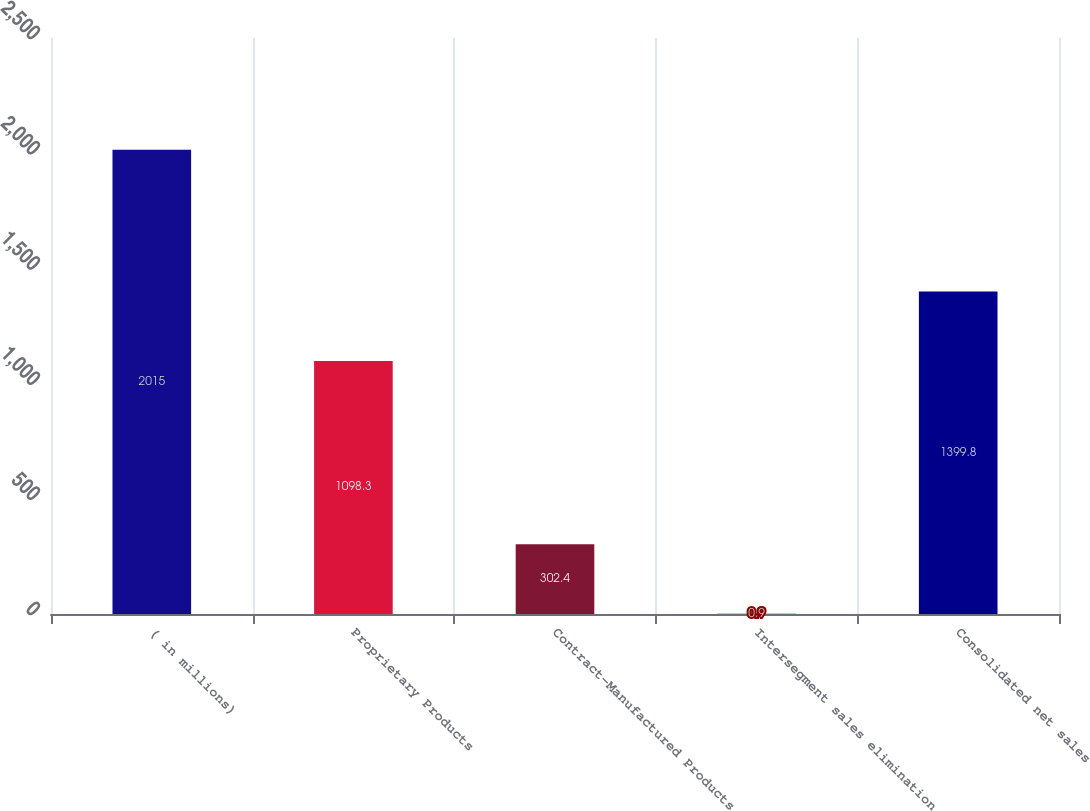Convert chart to OTSL. <chart><loc_0><loc_0><loc_500><loc_500><bar_chart><fcel>( in millions)<fcel>Proprietary Products<fcel>Contract-Manufactured Products<fcel>Intersegment sales elimination<fcel>Consolidated net sales<nl><fcel>2015<fcel>1098.3<fcel>302.4<fcel>0.9<fcel>1399.8<nl></chart> 